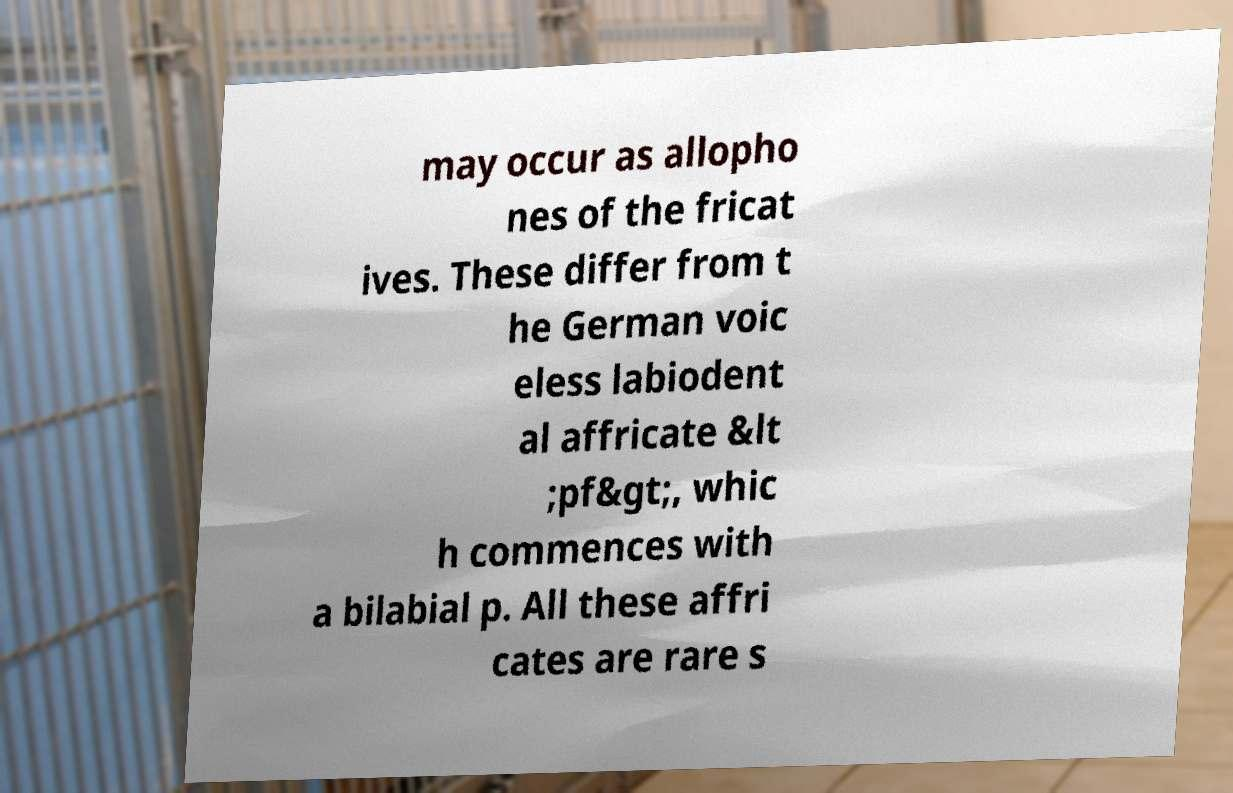I need the written content from this picture converted into text. Can you do that? may occur as allopho nes of the fricat ives. These differ from t he German voic eless labiodent al affricate &lt ;pf&gt;, whic h commences with a bilabial p. All these affri cates are rare s 